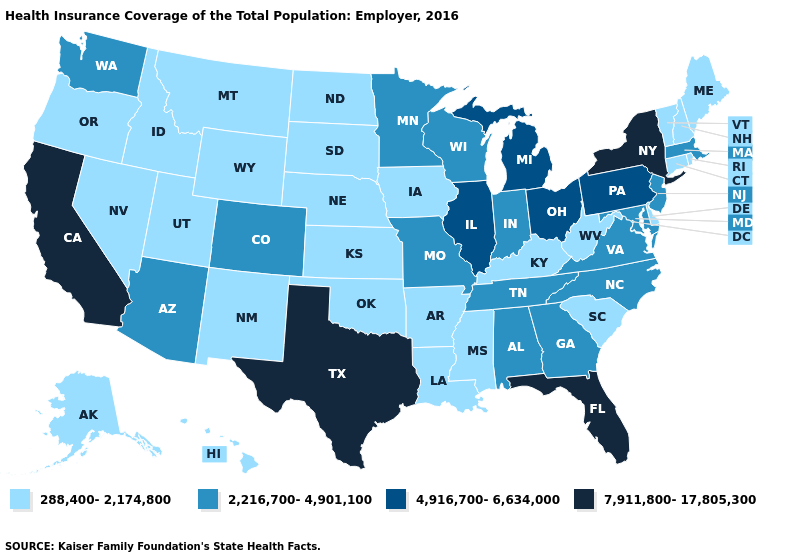Name the states that have a value in the range 288,400-2,174,800?
Write a very short answer. Alaska, Arkansas, Connecticut, Delaware, Hawaii, Idaho, Iowa, Kansas, Kentucky, Louisiana, Maine, Mississippi, Montana, Nebraska, Nevada, New Hampshire, New Mexico, North Dakota, Oklahoma, Oregon, Rhode Island, South Carolina, South Dakota, Utah, Vermont, West Virginia, Wyoming. What is the value of Washington?
Quick response, please. 2,216,700-4,901,100. What is the highest value in the West ?
Give a very brief answer. 7,911,800-17,805,300. Does Illinois have the highest value in the MidWest?
Be succinct. Yes. Name the states that have a value in the range 288,400-2,174,800?
Answer briefly. Alaska, Arkansas, Connecticut, Delaware, Hawaii, Idaho, Iowa, Kansas, Kentucky, Louisiana, Maine, Mississippi, Montana, Nebraska, Nevada, New Hampshire, New Mexico, North Dakota, Oklahoma, Oregon, Rhode Island, South Carolina, South Dakota, Utah, Vermont, West Virginia, Wyoming. Name the states that have a value in the range 7,911,800-17,805,300?
Write a very short answer. California, Florida, New York, Texas. What is the value of Louisiana?
Answer briefly. 288,400-2,174,800. Is the legend a continuous bar?
Write a very short answer. No. Is the legend a continuous bar?
Concise answer only. No. What is the value of South Dakota?
Be succinct. 288,400-2,174,800. What is the value of Montana?
Give a very brief answer. 288,400-2,174,800. Does Iowa have the highest value in the MidWest?
Keep it brief. No. Which states have the lowest value in the USA?
Short answer required. Alaska, Arkansas, Connecticut, Delaware, Hawaii, Idaho, Iowa, Kansas, Kentucky, Louisiana, Maine, Mississippi, Montana, Nebraska, Nevada, New Hampshire, New Mexico, North Dakota, Oklahoma, Oregon, Rhode Island, South Carolina, South Dakota, Utah, Vermont, West Virginia, Wyoming. What is the value of California?
Short answer required. 7,911,800-17,805,300. 